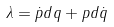Convert formula to latex. <formula><loc_0><loc_0><loc_500><loc_500>\lambda = \dot { p } d q + p d \dot { q }</formula> 